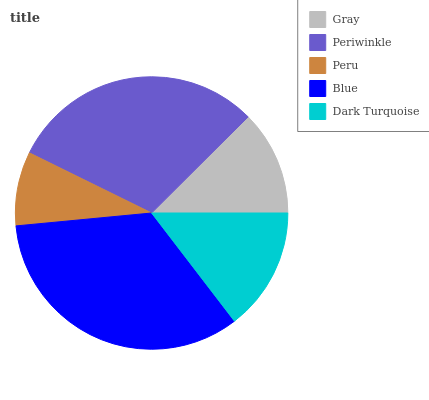Is Peru the minimum?
Answer yes or no. Yes. Is Blue the maximum?
Answer yes or no. Yes. Is Periwinkle the minimum?
Answer yes or no. No. Is Periwinkle the maximum?
Answer yes or no. No. Is Periwinkle greater than Gray?
Answer yes or no. Yes. Is Gray less than Periwinkle?
Answer yes or no. Yes. Is Gray greater than Periwinkle?
Answer yes or no. No. Is Periwinkle less than Gray?
Answer yes or no. No. Is Dark Turquoise the high median?
Answer yes or no. Yes. Is Dark Turquoise the low median?
Answer yes or no. Yes. Is Peru the high median?
Answer yes or no. No. Is Gray the low median?
Answer yes or no. No. 